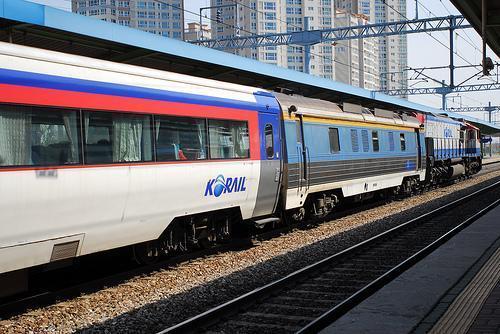How many trains are there?
Give a very brief answer. 1. 